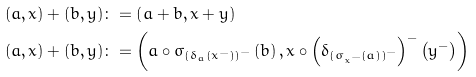Convert formula to latex. <formula><loc_0><loc_0><loc_500><loc_500>\left ( a , x \right ) + \left ( b , y \right ) & \colon = \left ( a + b , x + y \right ) \\ \left ( a , x \right ) + \left ( b , y \right ) & \colon = \left ( a \circ \sigma _ { \left ( \delta _ { a } \left ( x ^ { - } \right ) \right ) ^ { - } } \left ( b \right ) , x \circ \left ( \delta _ { \left ( \sigma _ { x ^ { - } } \left ( a \right ) \right ) ^ { - } } \right ) ^ { - } \left ( y ^ { - } \right ) \right )</formula> 